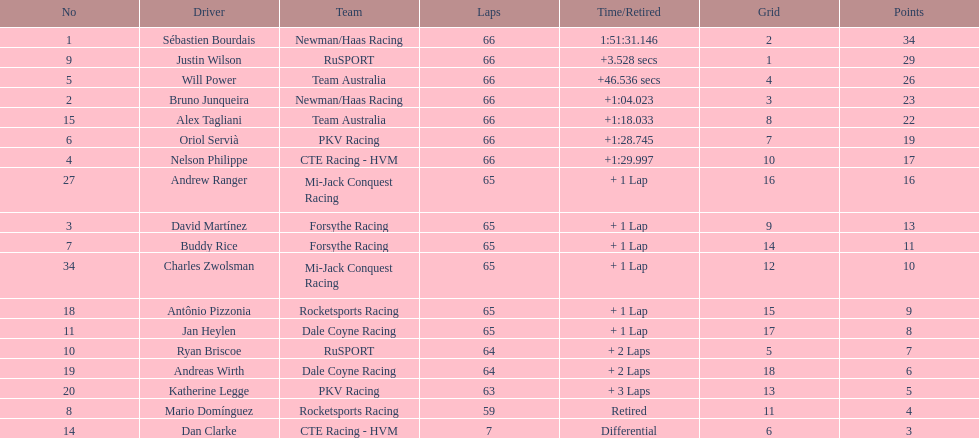Which country had more drivers representing them, the us or germany? Tie. 